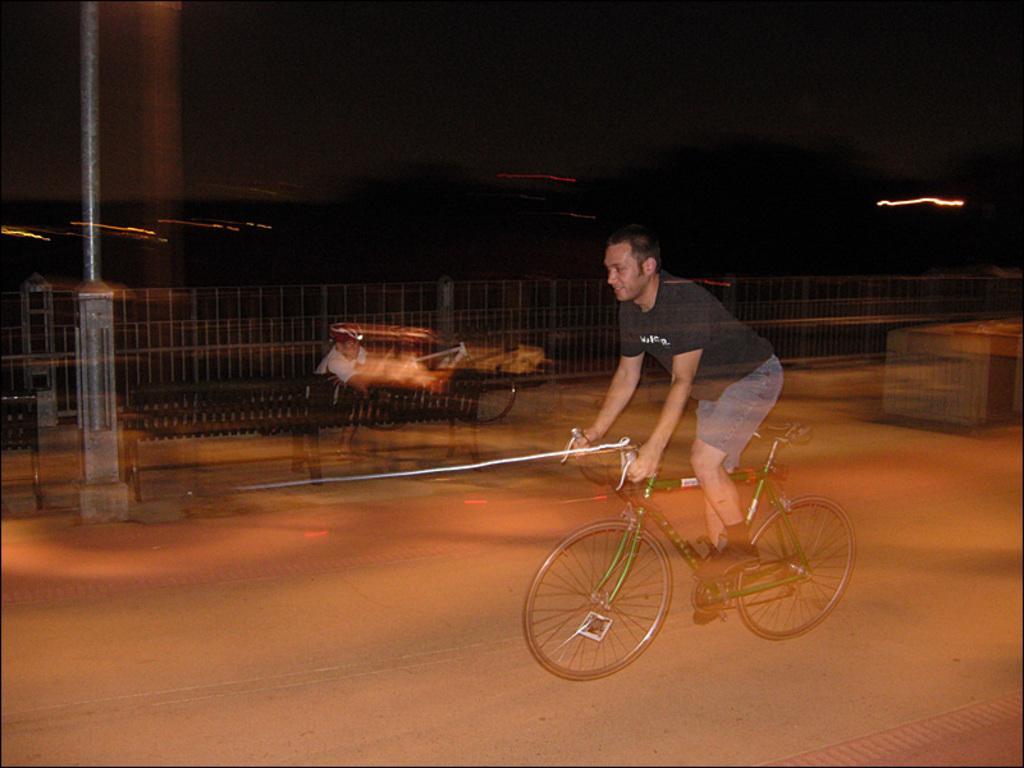Can you describe this image briefly? In this picture we can see a man is riding a bicycle on the road and another man is seated on the bench. 